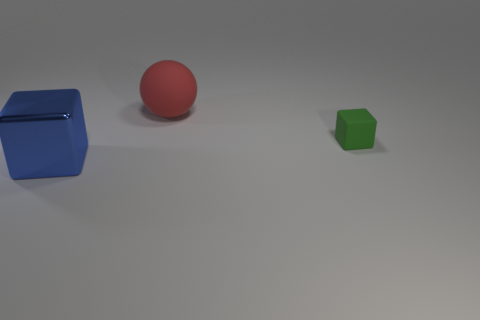How many other things are there of the same color as the large matte object?
Ensure brevity in your answer.  0. There is a block that is left of the red matte object; does it have the same size as the matte object that is behind the rubber cube?
Provide a short and direct response. Yes. The big thing on the left side of the big matte sphere is what color?
Offer a very short reply. Blue. Are there fewer big metal cubes that are on the right side of the large red ball than tiny balls?
Offer a terse response. No. Is the material of the red object the same as the big block?
Offer a very short reply. No. There is another green thing that is the same shape as the metallic object; what size is it?
Offer a terse response. Small. How many things are either blocks on the left side of the large matte sphere or large metallic cubes that are left of the tiny cube?
Provide a succinct answer. 1. Is the number of brown matte balls less than the number of big metallic cubes?
Ensure brevity in your answer.  Yes. Does the green thing have the same size as the block that is to the left of the big rubber ball?
Give a very brief answer. No. How many metal things are tiny blue cylinders or tiny blocks?
Provide a succinct answer. 0. 